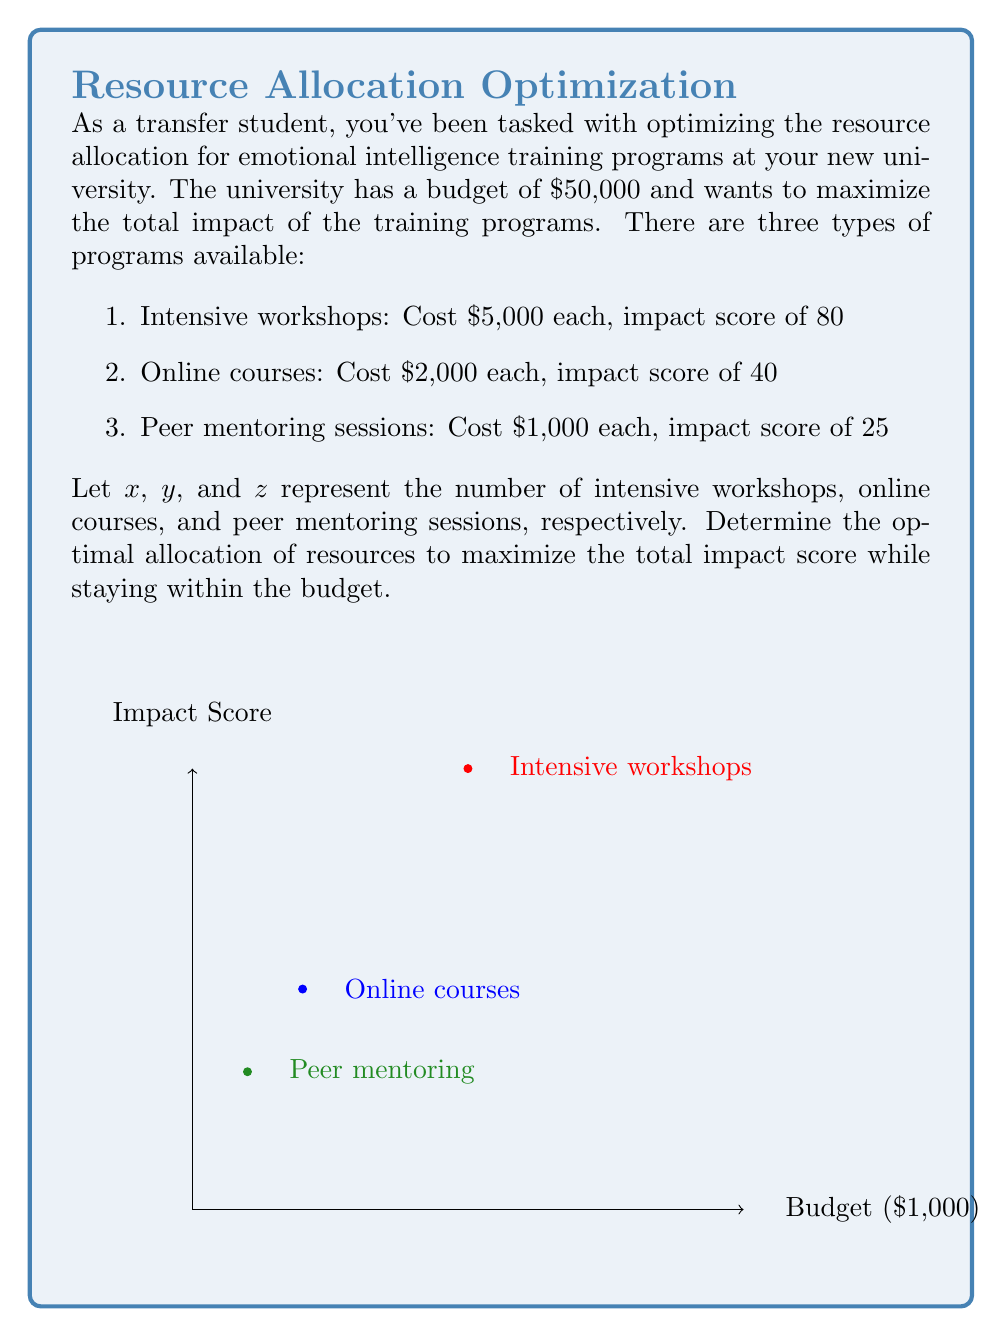Teach me how to tackle this problem. Let's approach this step-by-step using linear programming:

1) Define the objective function:
   Maximize $Z = 80x + 40y + 25z$

2) Define the constraints:
   Budget constraint: $5000x + 2000y + 1000z \leq 50000$
   Non-negativity: $x, y, z \geq 0$ and integer

3) Simplify the budget constraint:
   $5x + 2y + z \leq 50$

4) This is an Integer Linear Programming problem. We can solve it using the simplex method and then round down to the nearest integer solution.

5) Set up the initial simplex tableau:
   $$
   \begin{array}{c|cccc|c}
   & x & y & z & s & RHS \\
   \hline
   s & 5 & 2 & 1 & 1 & 50 \\
   \hline
   -Z & -80 & -40 & -25 & 0 & 0
   \end{array}
   $$

6) After performing simplex iterations, we get the optimal solution:
   $x = 10$, $y = 0$, $z = 0$

7) This gives us a maximum impact score of $80 * 10 = 800$

8) However, we have $50,000 - (10 * 5,000) = 0$ left in the budget, which isn't optimal.

9) Let's consider a mixed solution:
   9 intensive workshops: $9 * 5,000 = 45,000$
   2 online courses: $2 * 2,000 = 4,000$
   1 peer mentoring session: $1 * 1,000 = 1,000$
   Total cost: $50,000$
   Impact score: $(9 * 80) + (2 * 40) + (1 * 25) = 825$

This mixed solution provides a higher impact score while using the entire budget.
Answer: 9 intensive workshops, 2 online courses, 1 peer mentoring session 